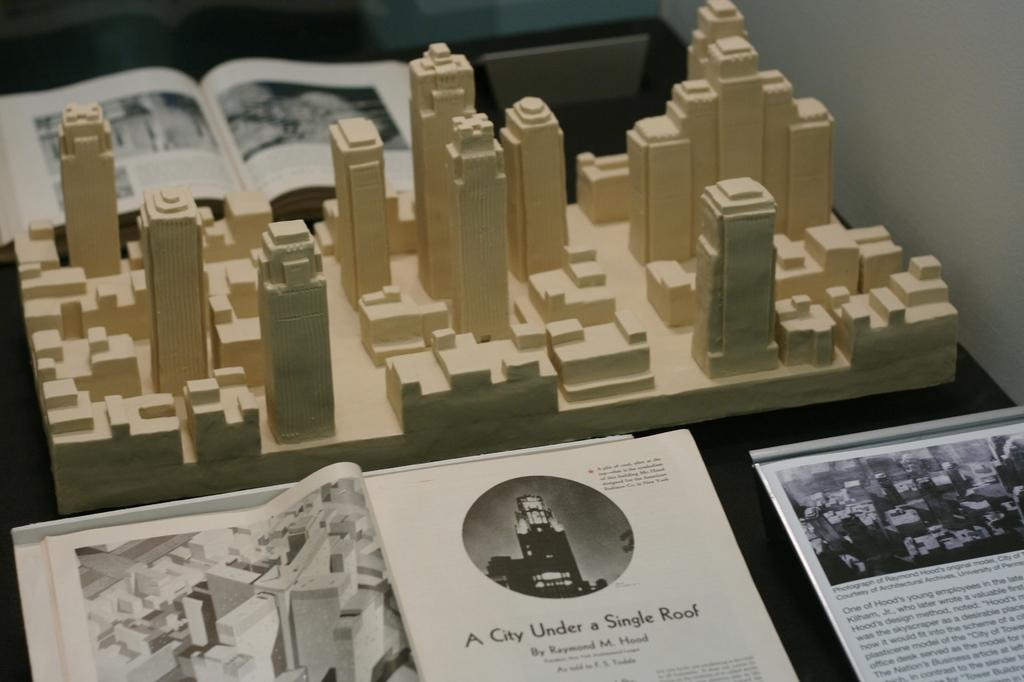What is placed on the table in the image? There is a module of buildings on a table. What is located on either side of the module? There are magazines on either side of the module. What can be found within the magazines? The magazines contain images and information. What type of quilt is draped over the module of buildings in the image? There is no quilt present in the image; it features a module of buildings and magazines. What type of linen is used to cover the table in the image? The image does not provide information about the table's covering, so it cannot be determined from the image. 